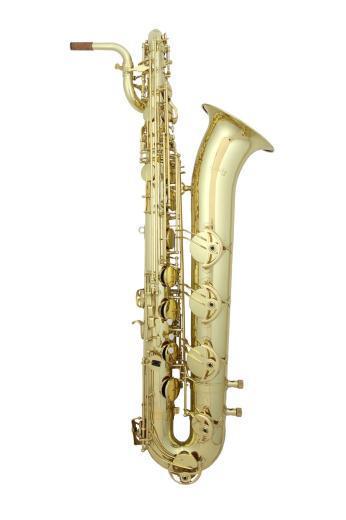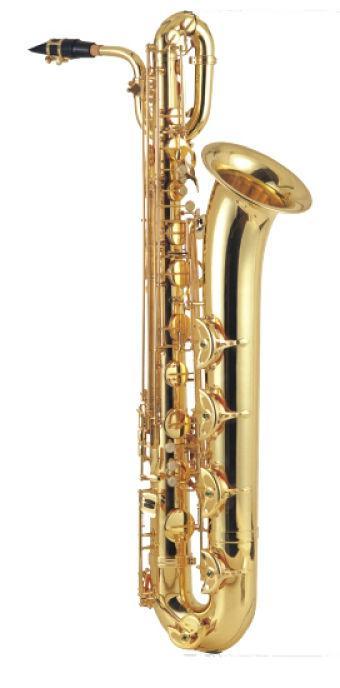The first image is the image on the left, the second image is the image on the right. Evaluate the accuracy of this statement regarding the images: "The saxophone on the left has a black mouthpiece and is displayed vertically, while the saxophone on the right has no dark mouthpiece and is tilted to the right.". Is it true? Answer yes or no. No. The first image is the image on the left, the second image is the image on the right. Evaluate the accuracy of this statement regarding the images: "The sax on the left is missing a mouthpiece.". Is it true? Answer yes or no. No. 